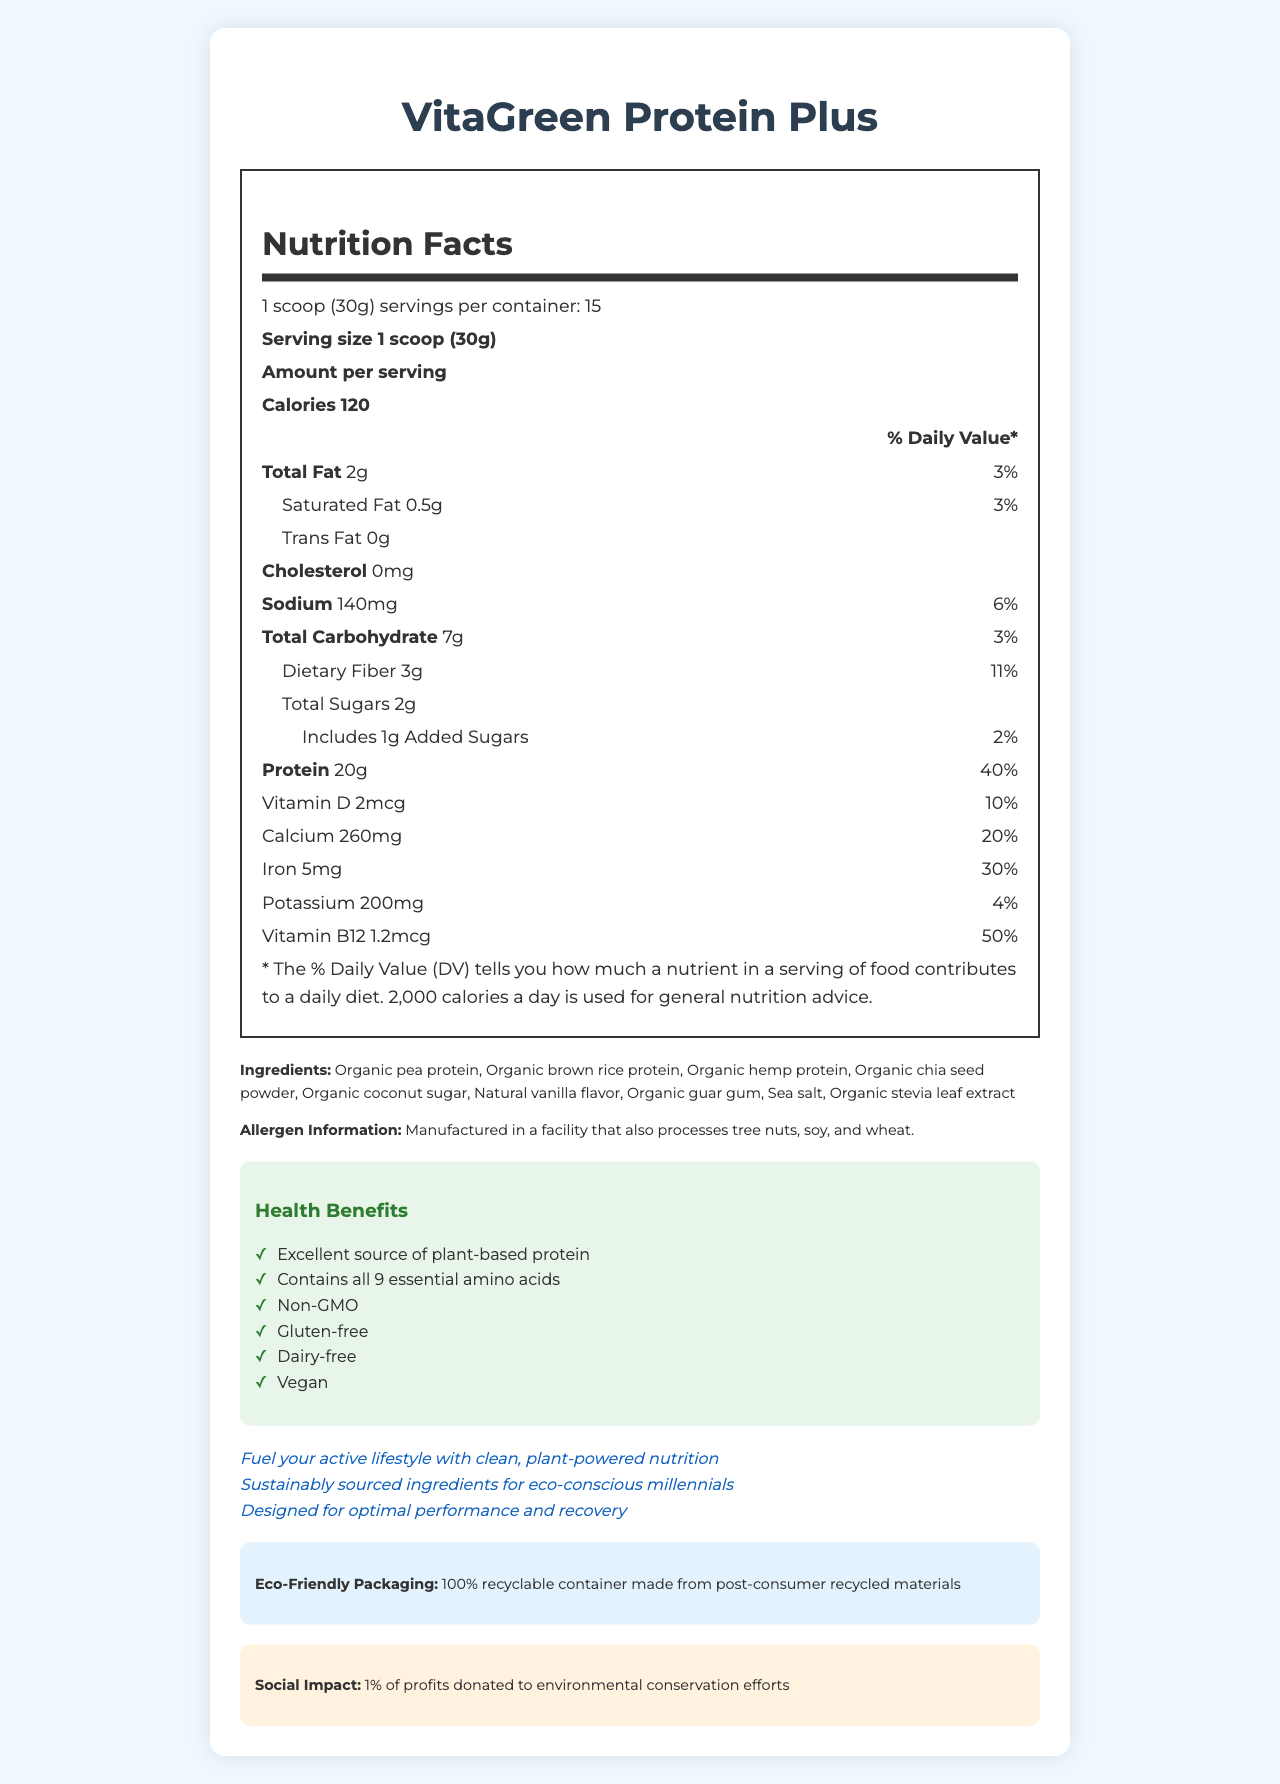what is the serving size of VitaGreen Protein Plus? The serving size is specified in the nutrition facts section as "1 scoop (30g)".
Answer: 1 scoop (30g) what percentage of daily value for protein does one serving provide? According to the nutrition facts, one serving provides 20g of protein, which is 40% of the daily value.
Answer: 40% how many calories are in one serving of VitaGreen Protein Plus? The number of calories per serving is listed in the nutrition facts section as 120 calories.
Answer: 120 what is the total carbohydrate content per serving? The total carbohydrate content per serving is mentioned as 7g in the nutrition facts.
Answer: 7g what vitamins and minerals are included in one serving of VitaGreen Protein Plus? The nutrition facts section lists Vitamin D, Calcium, Iron, Potassium, and Vitamin B12 with their respective amounts and daily values.
Answer: Vitamin D, Calcium, Iron, Potassium, Vitamin B12 which ingredients are used in VitaGreen Protein Plus? The ingredients are listed under the ingredients section in the document.
Answer: Organic pea protein, Organic brown rice protein, Organic hemp protein, Organic chia seed powder, Organic coconut sugar, Natural vanilla flavor, Organic guar gum, Sea salt, Organic stevia leaf extract what are the health benefits of VitaGreen Protein Plus? A. High protein content B. Contains essential amino acids C. Non-GMO D. All of the above The health benefits section lists all three options: high protein content, contains essential amino acids, and non-GMO.
Answer: D which of the following is a health claim stated for VitaGreen Protein Plus? I. Excellent source of plant-based protein II. Contains all 9 essential amino acids III. Made with organic sugar IV. Vegan The health claims section mentions, "Excellent source of plant-based protein," "Contains all 9 essential amino acids," and "Vegan." "Made with organic sugar" is not listed as a health claim.
Answer: I, II, and IV is VitaGreen Protein Plus gluten-free? The health claims section lists "Gluten-free" indicating that the product is gluten-free.
Answer: Yes is the packaging of VitaGreen Protein Plus eco-friendly? The document states that the packaging is a 100% recyclable container made from post-consumer recycled materials.
Answer: Yes summarize the main idea of the document in one sentence. The document highlights the nutritional benefits, ingredients, health claims, eco-friendly packaging, and social impact of VitaGreen Protein Plus targeting health-conscious millennials.
Answer: VitaGreen Protein Plus offers a plant-based protein shake featuring high protein content, multiple essential nutrients, eco-friendly packaging, and a commitment to environmental conservation, aimed at health-conscious millennials. how many calories from fat does VitaGreen Protein Plus contain? The document provides total fat content and calories per serving but does not specify calories from fat directly.
Answer: Not enough information 